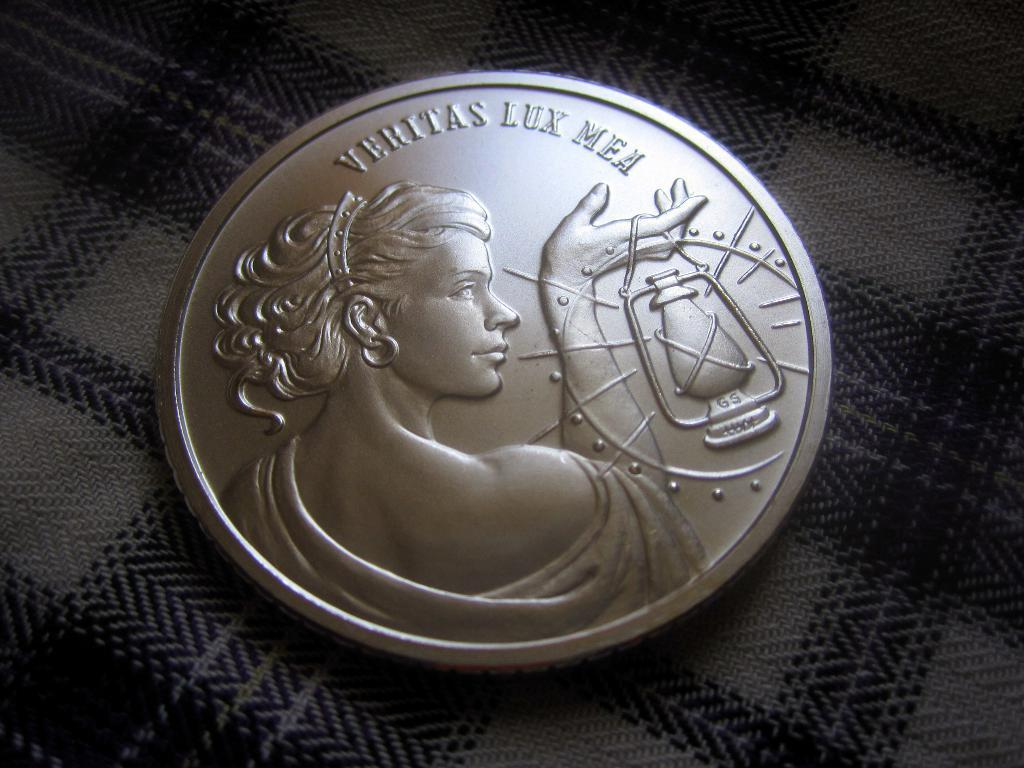<image>
Describe the image concisely. a coin reading Veritas Lux Mea with a woman holding up a lantern 